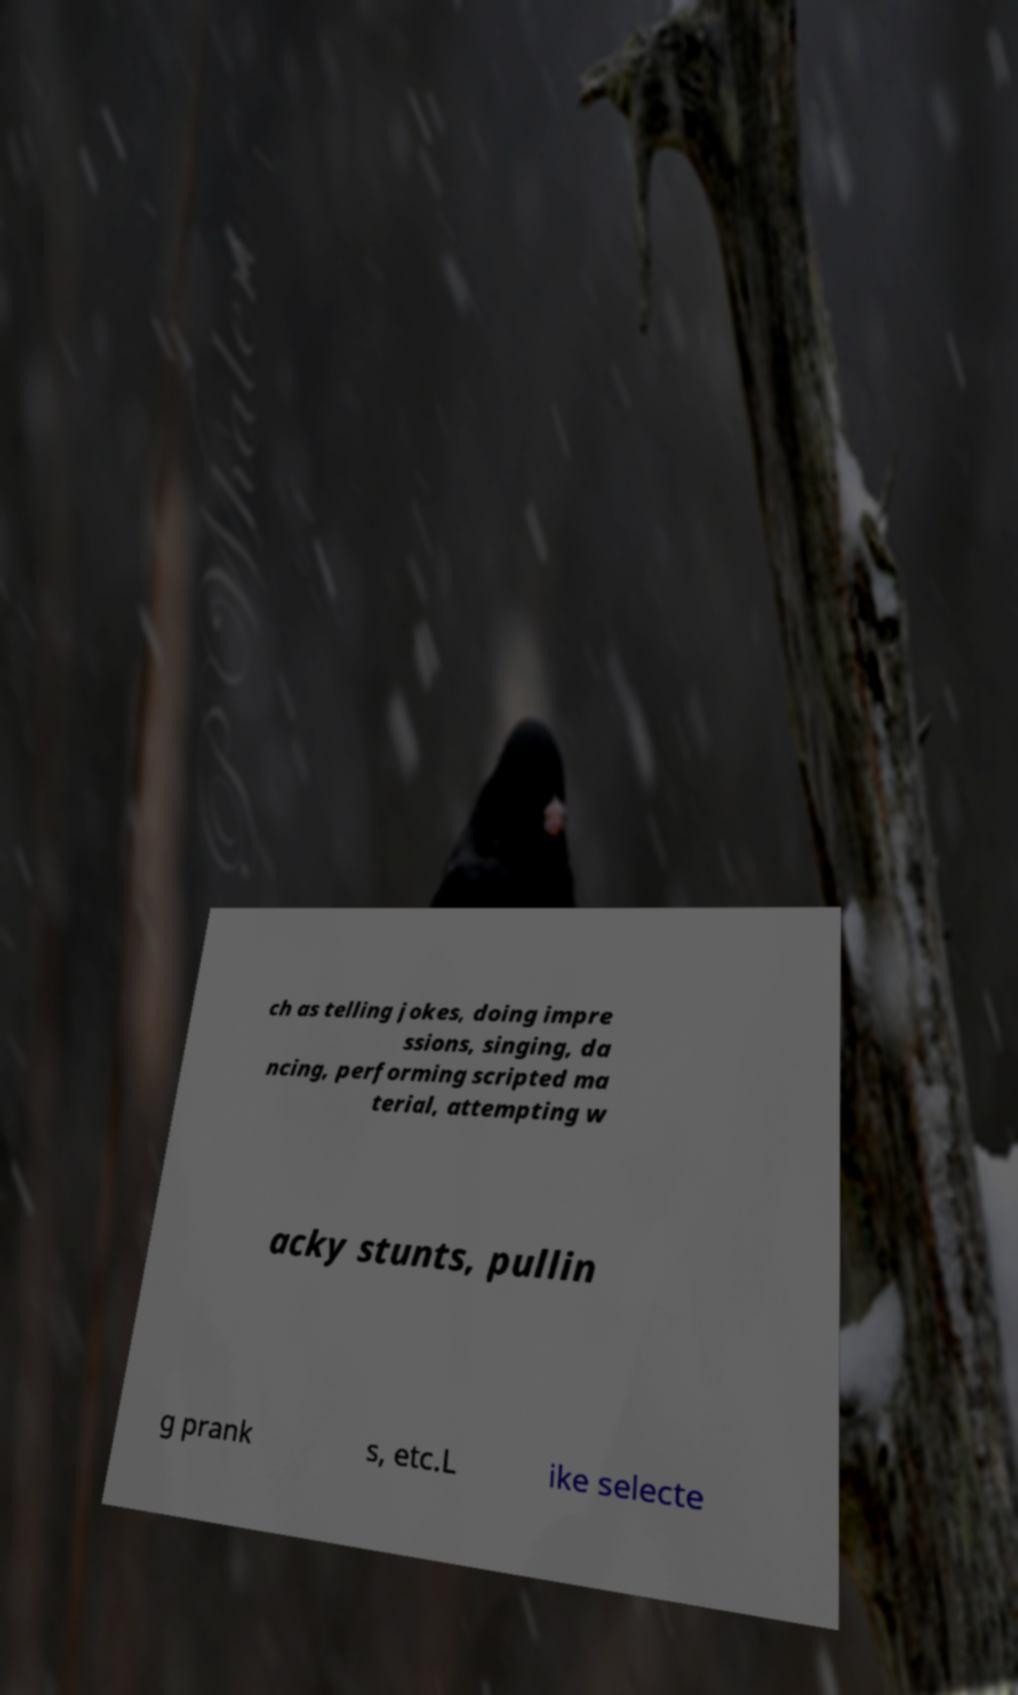I need the written content from this picture converted into text. Can you do that? ch as telling jokes, doing impre ssions, singing, da ncing, performing scripted ma terial, attempting w acky stunts, pullin g prank s, etc.L ike selecte 